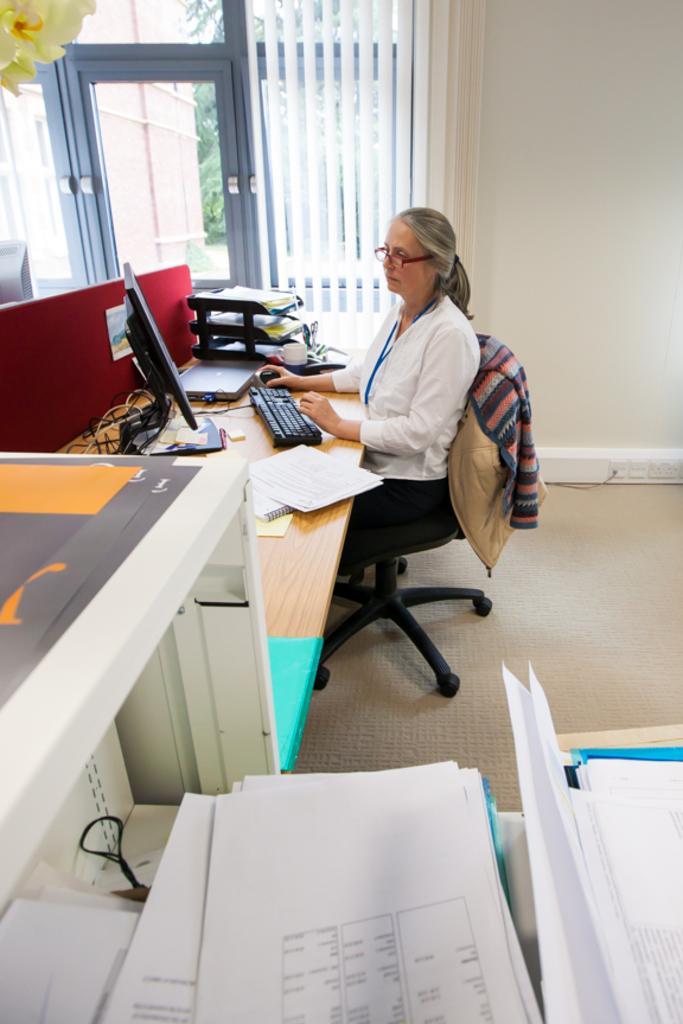How would you summarize this image in a sentence or two? In this image there is a woman sitting on a black chair, she is looking into a computer. There is a computer, keyboard,cup, papers, books, papers, wires on the desk. At the back there is a door, at the front there are papers and a machine. 